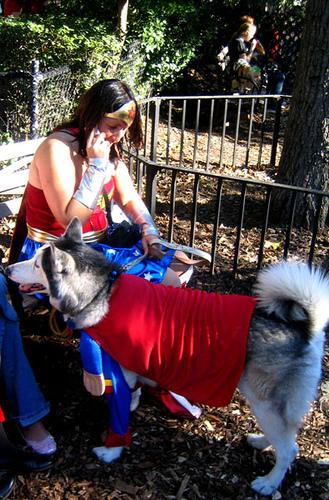Identify two objects in the background and an object in the foreground. Two objects in the background are kids standing and a bush with green leaves, while an object in the foreground is the black fence surrounding the tree. Mention three parts of the dog's face that are visible. The black nose, an eye, and the mouth. Describe the scene where the tree and the fence are presented. A brown oak tree is enclosed by a black wrought iron fence, with its shadow being reflected by sunlight on the ground. What is the relationship between the woman and the dog? The woman is holding the dog's leash, implying that she is the dog's owner. Analyze the interaction between the woman and the dog. The woman is holding the dog's leash and appears to be engaged in conversation on her phone, while the dog is wearing a superhero costume, showing a playful and friendly relationship. What kind of dog is shown in the image and what does it wear? A black and white husky or Siberian Husky wearing a superhero costume with a red cape. What is this sentence about: "A _ on the _ is seen near the _ and the _" A pink shoe on the ground is seen near the dog and the woman. In the following sentence, complete the phrase: "The woman is talking on her _ while dressed as _" The woman is talking on her phone while dressed as Wonder Woman. Count the number of objects related to clothing or costume in the image. Eleven objects are related to clothing or costume, such as the red cape, the Wonder Woman headband, and the blue jeans. Identify the main characters in the image and their outfits. A woman dressed as Wonder Woman and a black and white dog wearing a Superman costume with a red cape. 